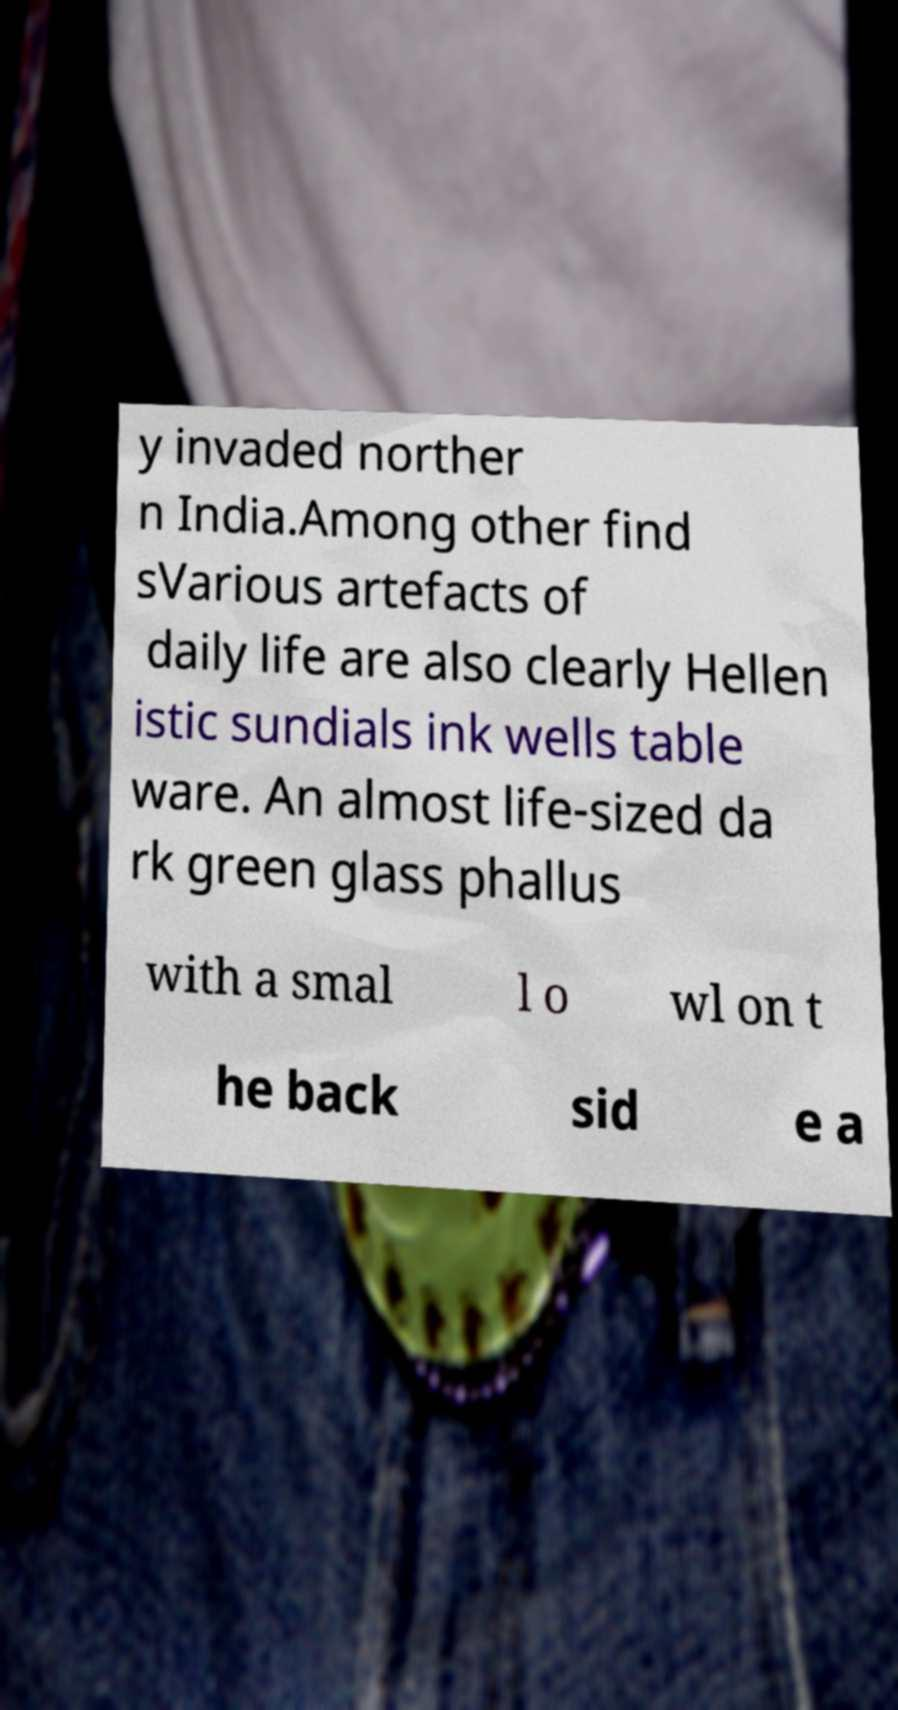Could you extract and type out the text from this image? y invaded norther n India.Among other find sVarious artefacts of daily life are also clearly Hellen istic sundials ink wells table ware. An almost life-sized da rk green glass phallus with a smal l o wl on t he back sid e a 